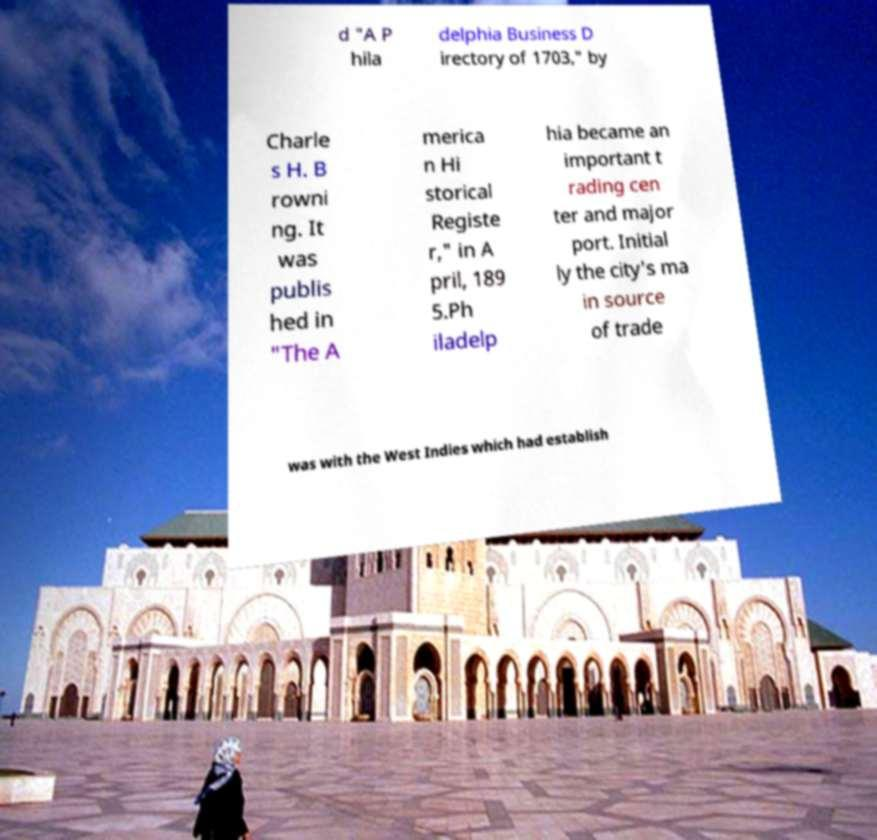Please identify and transcribe the text found in this image. d "A P hila delphia Business D irectory of 1703," by Charle s H. B rowni ng. It was publis hed in "The A merica n Hi storical Registe r," in A pril, 189 5.Ph iladelp hia became an important t rading cen ter and major port. Initial ly the city's ma in source of trade was with the West Indies which had establish 